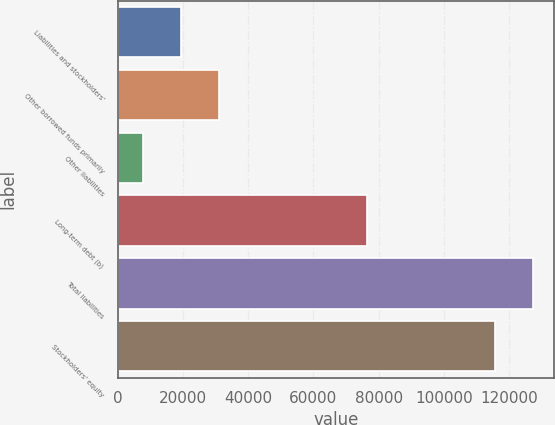Convert chart to OTSL. <chart><loc_0><loc_0><loc_500><loc_500><bar_chart><fcel>Liabilities and stockholders'<fcel>Other borrowed funds primarily<fcel>Other liabilities<fcel>Long-term debt (b)<fcel>Total liabilities<fcel>Stockholders' equity<nl><fcel>19282.5<fcel>30960<fcel>7605<fcel>76581<fcel>127468<fcel>115790<nl></chart> 